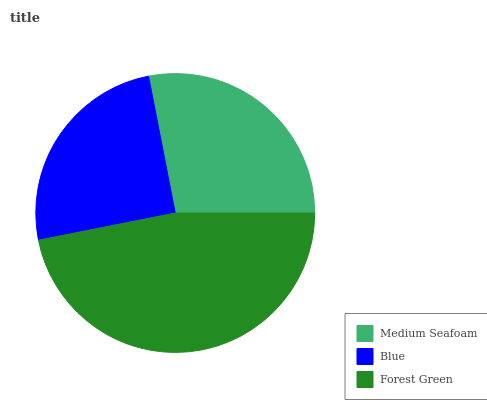Is Blue the minimum?
Answer yes or no. Yes. Is Forest Green the maximum?
Answer yes or no. Yes. Is Forest Green the minimum?
Answer yes or no. No. Is Blue the maximum?
Answer yes or no. No. Is Forest Green greater than Blue?
Answer yes or no. Yes. Is Blue less than Forest Green?
Answer yes or no. Yes. Is Blue greater than Forest Green?
Answer yes or no. No. Is Forest Green less than Blue?
Answer yes or no. No. Is Medium Seafoam the high median?
Answer yes or no. Yes. Is Medium Seafoam the low median?
Answer yes or no. Yes. Is Blue the high median?
Answer yes or no. No. Is Forest Green the low median?
Answer yes or no. No. 